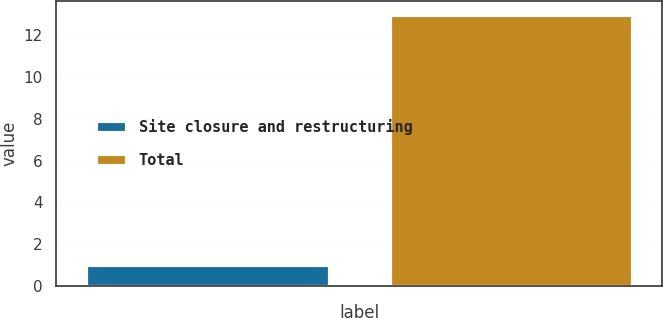Convert chart to OTSL. <chart><loc_0><loc_0><loc_500><loc_500><bar_chart><fcel>Site closure and restructuring<fcel>Total<nl><fcel>1<fcel>13<nl></chart> 